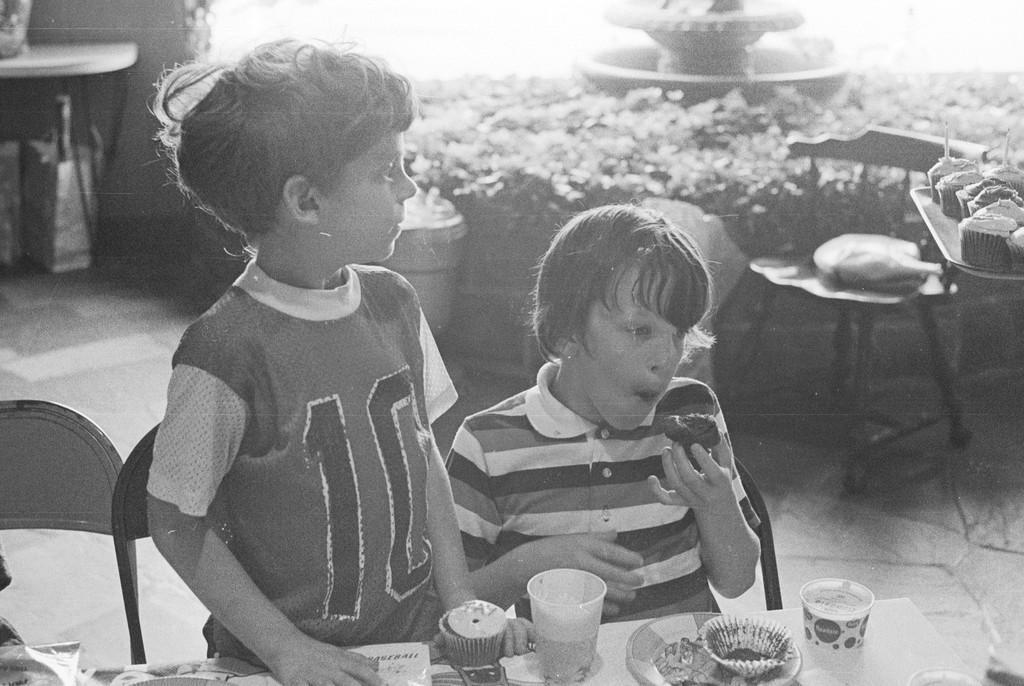Please provide a concise description of this image. As we can see in the image, there are plants, tables and chairs and two people over here. On table there are plates and glasses. 